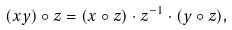Convert formula to latex. <formula><loc_0><loc_0><loc_500><loc_500>( x y ) \circ z = ( x \circ z ) \cdot z ^ { - 1 } \cdot ( y \circ z ) ,</formula> 